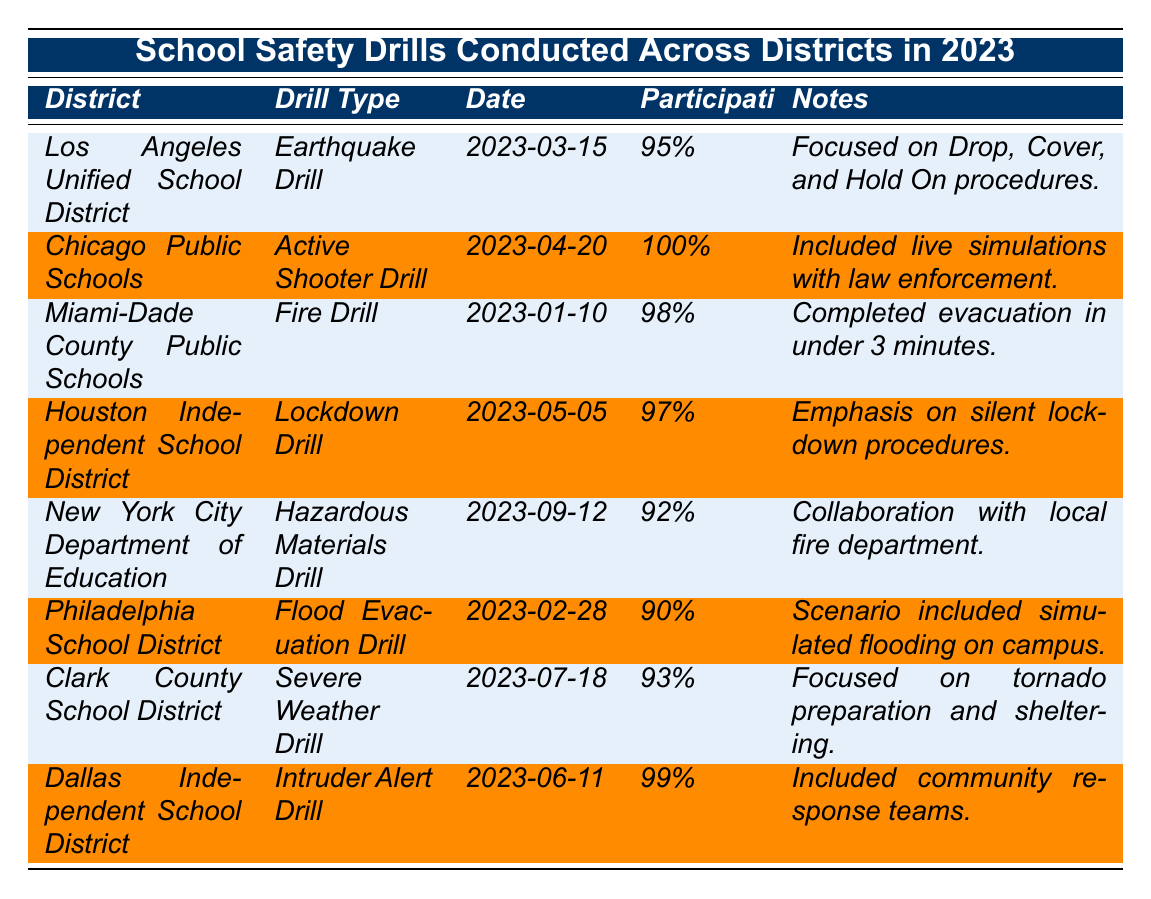What drill type was conducted by the Chicago Public Schools? The table indicates that the Chicago Public Schools conducted an Active Shooter Drill.
Answer: Active Shooter Drill Which district had the highest participation rate? By examining the participation rates listed in the table, it is clear that Chicago Public Schools had a participation rate of 100%, which is the highest.
Answer: Chicago Public Schools What was the date of the Fire Drill conducted by Miami-Dade County Public Schools? The table specifies that the Fire Drill was conducted on January 10, 2023, by Miami-Dade County Public Schools.
Answer: 2023-01-10 Which drill had a focus on tornado preparation? The table shows that the Clark County School District conducted a Severe Weather Drill, which focused on tornado preparation and sheltering.
Answer: Severe Weather Drill Did any district have a participation rate below 90%? Reviewing the table, the Philadelphia School District had a participation rate of 90%, and no district is noted below this percentage, so the answer is no.
Answer: No What is the average participation rate of the drills conducted? The participation rates are 95%, 100%, 98%, 97%, 92%, 90%, 93%, and 99%. Summing these gives  95 + 100 + 98 + 97 + 92 + 90 + 93 + 99 = 764. There are 8 drills, so the average rate is 764/8 = 95.5%.
Answer: 95.5% Which drill involved collaboration with local law enforcement? According to the table, the Active Shooter Drill conducted by Chicago Public Schools included live simulations with law enforcement.
Answer: Active Shooter Drill Was the Flood Evacuation Drill conducted before the Lockdown Drill? Referring to the dates, the Flood Evacuation Drill was conducted on February 28, 2023, and the Lockdown Drill was on May 5, 2023. Since February comes before May, the answer is yes.
Answer: Yes What training focus did the Lockdown Drill emphasize? The table notes that the Lockdown Drill conducted in the Houston Independent School District emphasized silent lockdown procedures.
Answer: Silent lockdown procedures How many districts conducted drills in the first half of 2023? Looking at the dates, drills in the first half include Miami-Dade (Jan), Philadelphia (Feb), Los Angeles (Mar), Chicago (Apr), and Houston (May) totaling to 5 distinct districts.
Answer: 5 